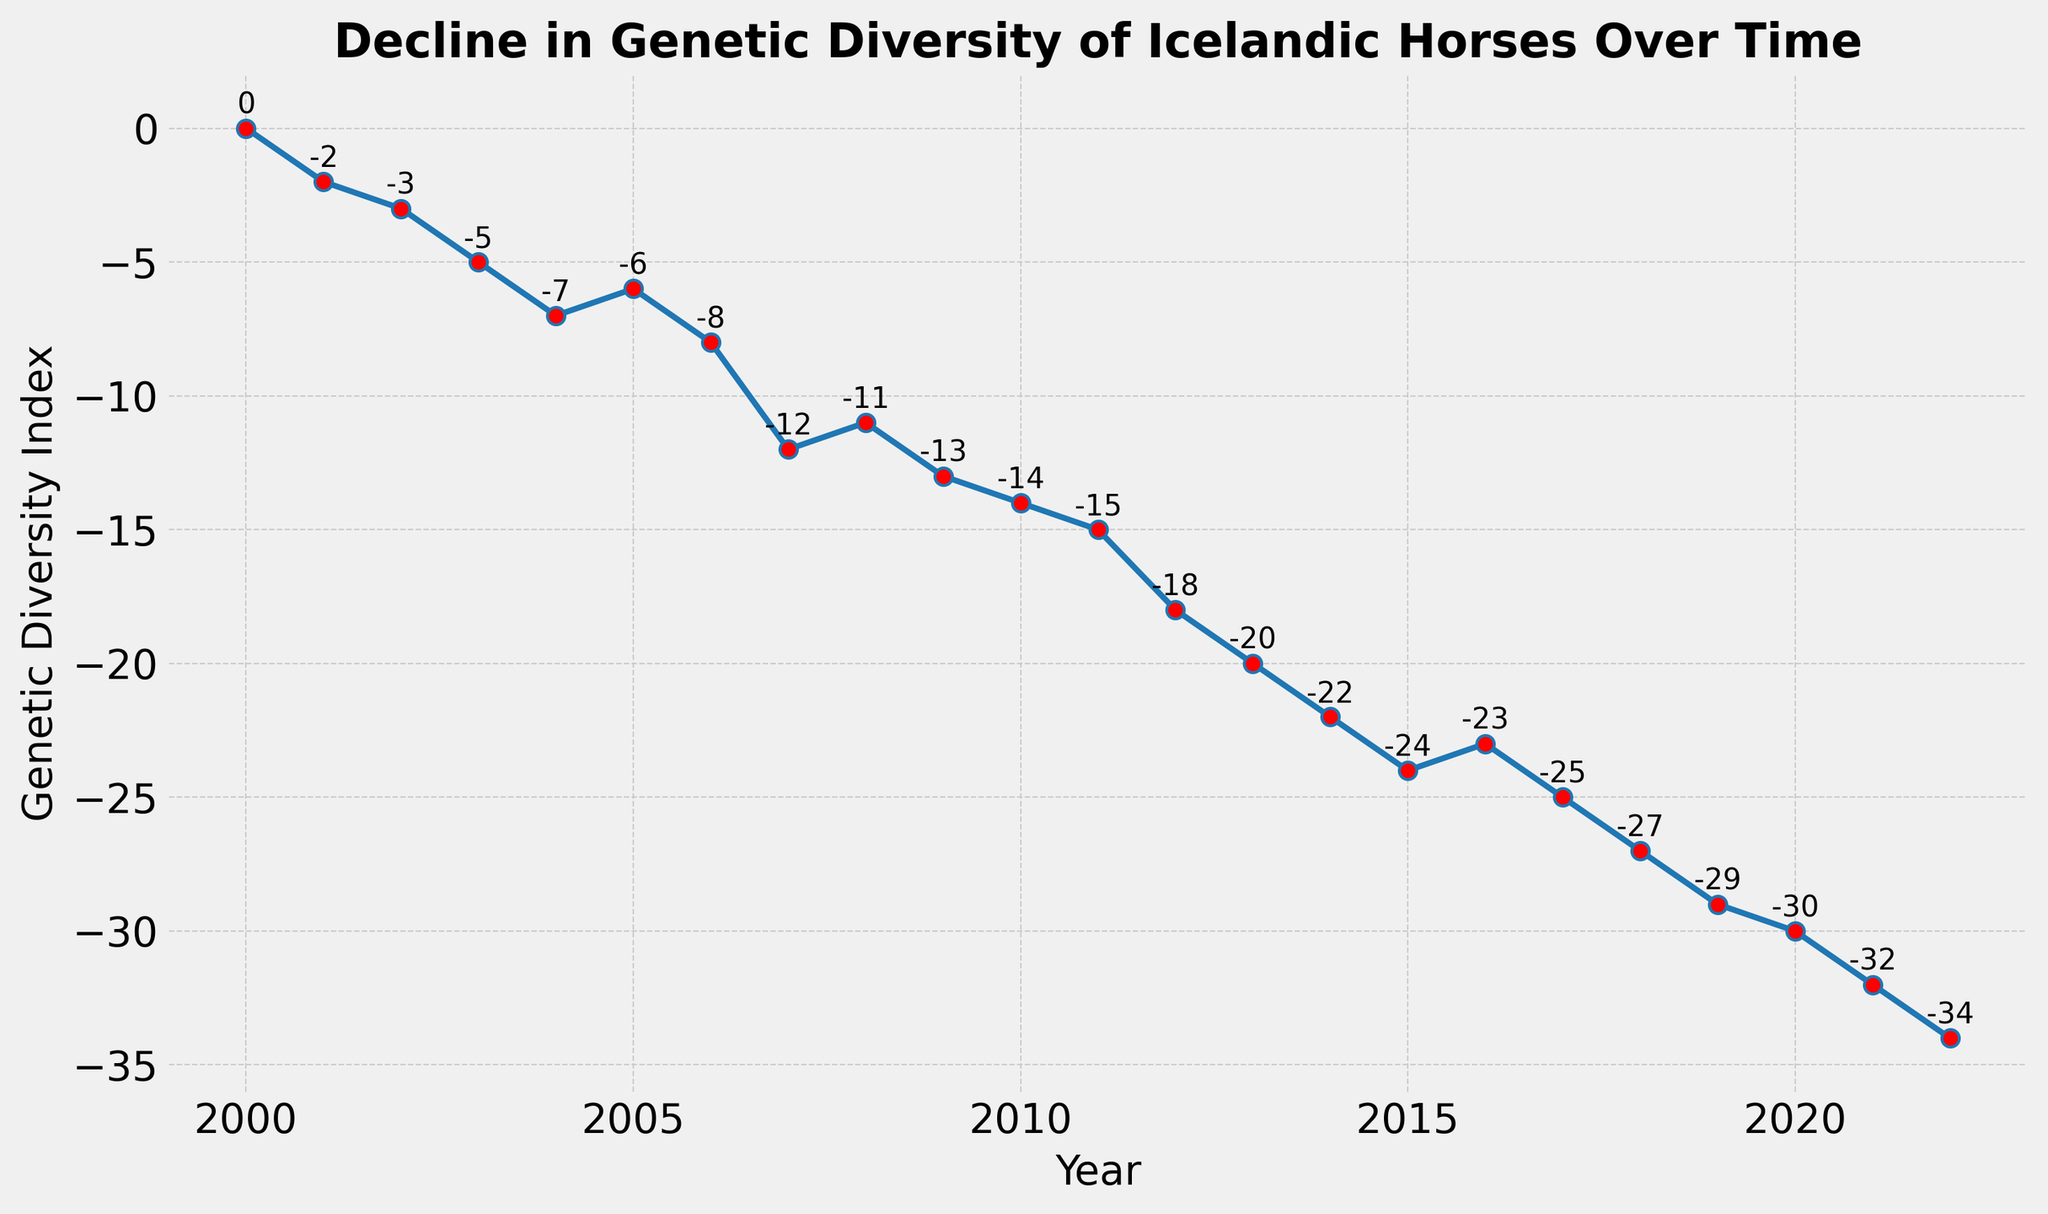Which year shows the lowest Genetic Diversity Index? By looking at the figure, the year with the lowest point on the y-axis indicates the lowest Genetic Diversity Index. Clearly, the year 2022 has the lowest value at -34.
Answer: 2022 How many years show a Genetic Diversity Index of less than -20? To determine this, count the number of points on the graph with values below -20. The points for the years 2013, 2014, 2015, 2017, 2018, 2019, 2020, 2021, and 2022 meet this criterion. That's 9 years.
Answer: 9 Did the Genetic Diversity Index ever increase between consecutive years? By observing the trend lines and data points, there is one instance where the Genetic Diversity Index increased: between 2015 and 2016, where it goes from -24 to -23.
Answer: Yes Calculate the average Genetic Diversity Index for the years 2010 to 2015 inclusive. To find the average, sum the Genetic Diversity Index values from 2010 to 2015, then divide by the number of years. (-14 + -15 + -18 + -20 + -22 + -24) / 6 = -113 / 6 = -18.83
Answer: -18.83 In which year was the largest year-over-year drop in Genetic Diversity Index recorded? The largest drop is observed by calculating the differences between consecutive years, and the biggest drop is from 2006 to 2007 (-8 to -12, a drop of 4 units).
Answer: 2007 How does the Genetic Diversity Index in 2010 compare to that in 2005? Look at the values for the respective years. In 2010, the index is -14; in 2005, it is -6, indicating the 2010 value is lower by 8 units.
Answer: -14 is lower by 8 units What is the difference in the Genetic Diversity Index between the years 2000 and 2022? Subtract the 2000 value from the 2022 value. 0 - (-34) = 34
Answer: 34 Identify the trend from 2000 to 2007. Observe the overall direction of the line from 2000 to 2007. The Genetic Diversity Index consistently decreases from 0 in 2000 to -12 in 2007.
Answer: Decreasing trend Which year showed the smallest decline in Genetic Diversity Index compared to its preceding year? Calculate the differences Year by Year. The smallest decline is between 2008 and 2009, where it changes from -11 to -13, a decrease of only 2 units.
Answer: 2009 When comparing the first (2000) and last (2022) years of data, what is the percentage change in Genetic Diversity Index? Calculate the percentage change as ((final value - initial value) / initial value) * 100 = ((-34 - 0) / 0) * 100. The value for the starting year (2000) is 0, hence percentage change can't be defined. The important observation is the shift from 0 to -34 over 22 years.
Answer: Essentially undefined, but -34 over 22 years 